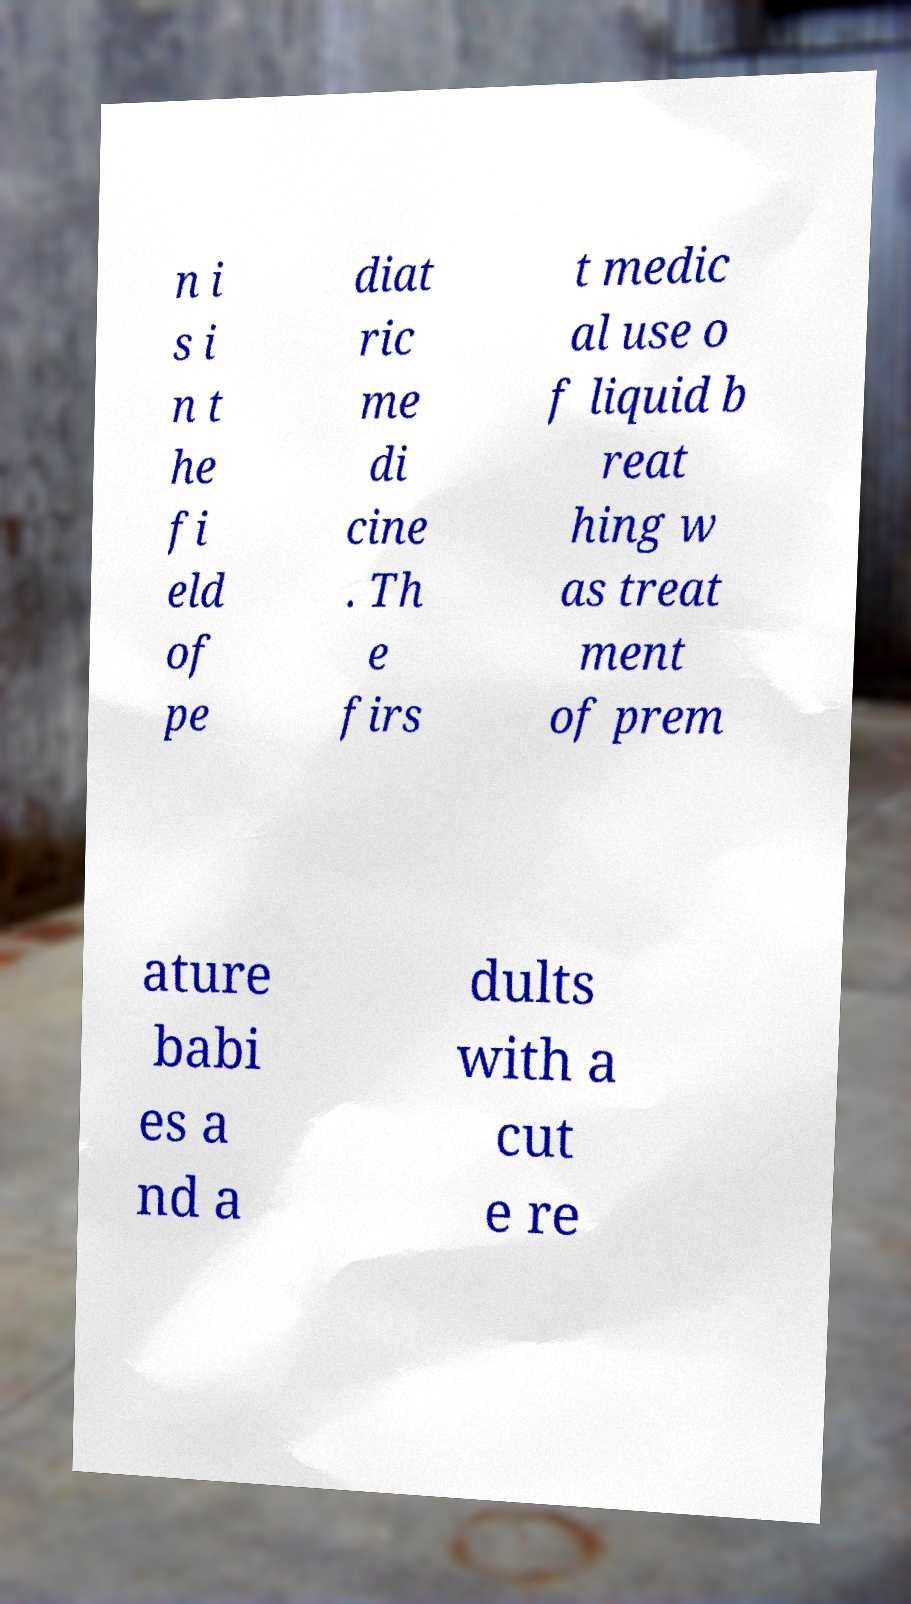Can you accurately transcribe the text from the provided image for me? n i s i n t he fi eld of pe diat ric me di cine . Th e firs t medic al use o f liquid b reat hing w as treat ment of prem ature babi es a nd a dults with a cut e re 